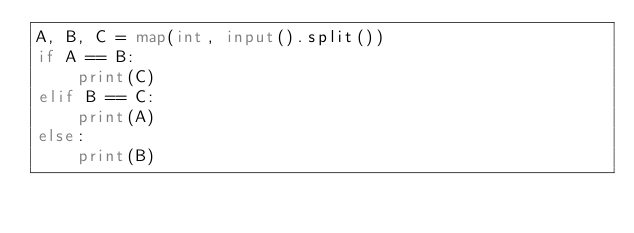Convert code to text. <code><loc_0><loc_0><loc_500><loc_500><_Python_>A, B, C = map(int, input().split())
if A == B:
    print(C)
elif B == C:
    print(A)
else:
    print(B)</code> 